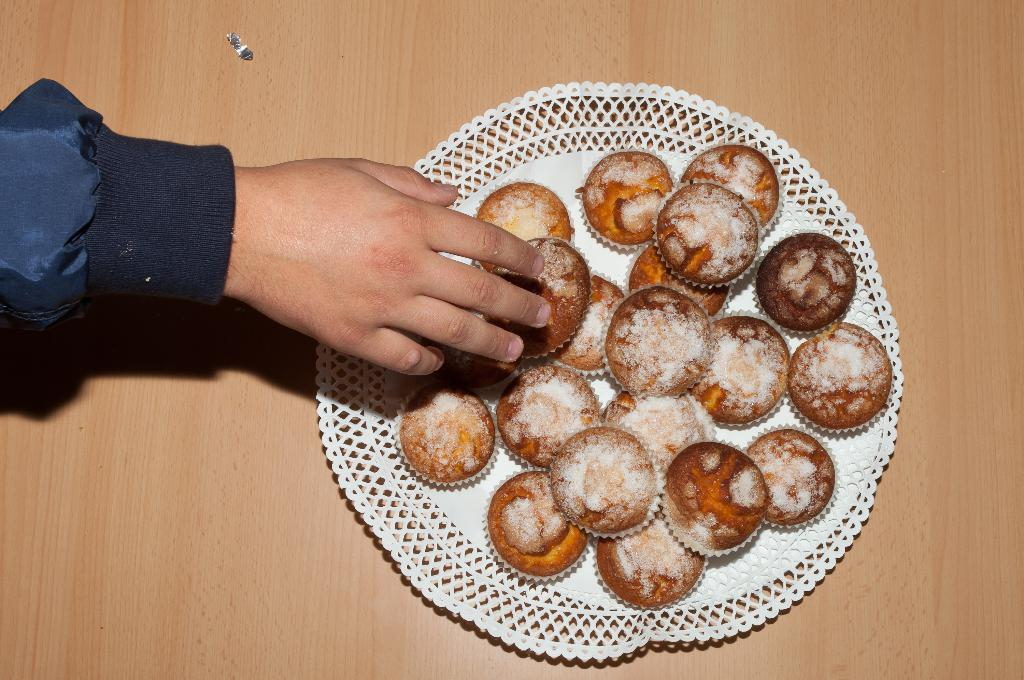What type of food is present on the plate in the image? There are muffins in a plate in the image. Can you describe anything else visible on the left side of the image? There is a human hand on the left side of the image. Are there any snails crawling on the muffins in the image? No, there are no snails present in the image. Is anyone attacking the muffins in the image? No, there is no indication of an attack on the muffins in the image. 